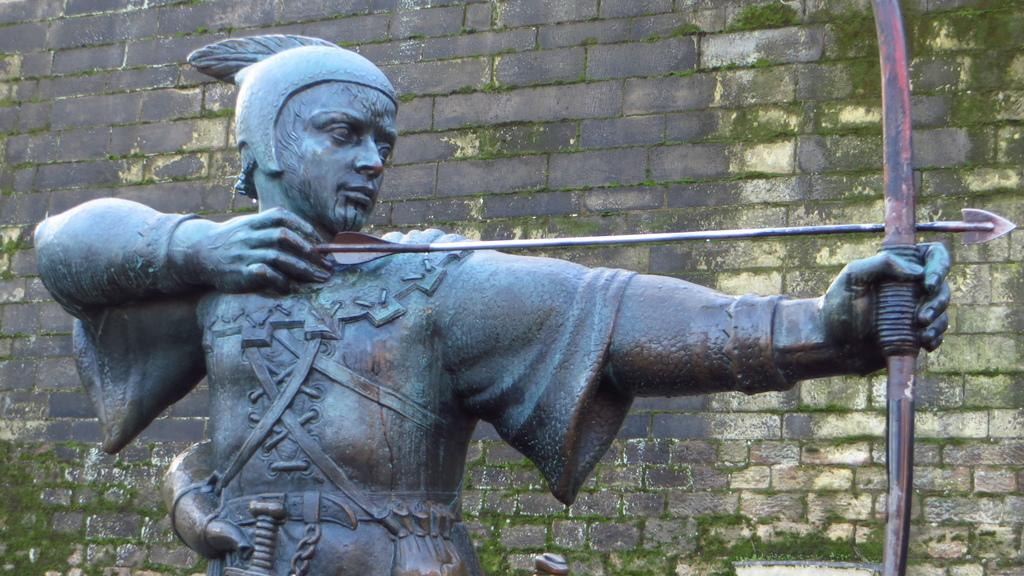What is the main subject of the image? There is a sculpture of a man in the image. What is the man holding in the sculpture? The man is holding a bow and an arrow. What can be seen in the background of the image? There is a wall in the background of the image. What type of flesh can be seen on the rabbit in the image? There is no rabbit present in the image, and therefore no flesh can be seen. What type of leather is used to make the man's clothing in the image? The image is a sculpture, and it does not depict actual clothing made of leather. 